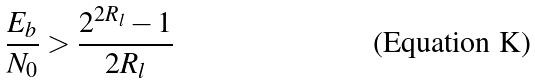<formula> <loc_0><loc_0><loc_500><loc_500>\frac { E _ { b } } { N _ { 0 } } > \frac { 2 ^ { 2 R _ { l } } - 1 } { 2 R _ { l } }</formula> 